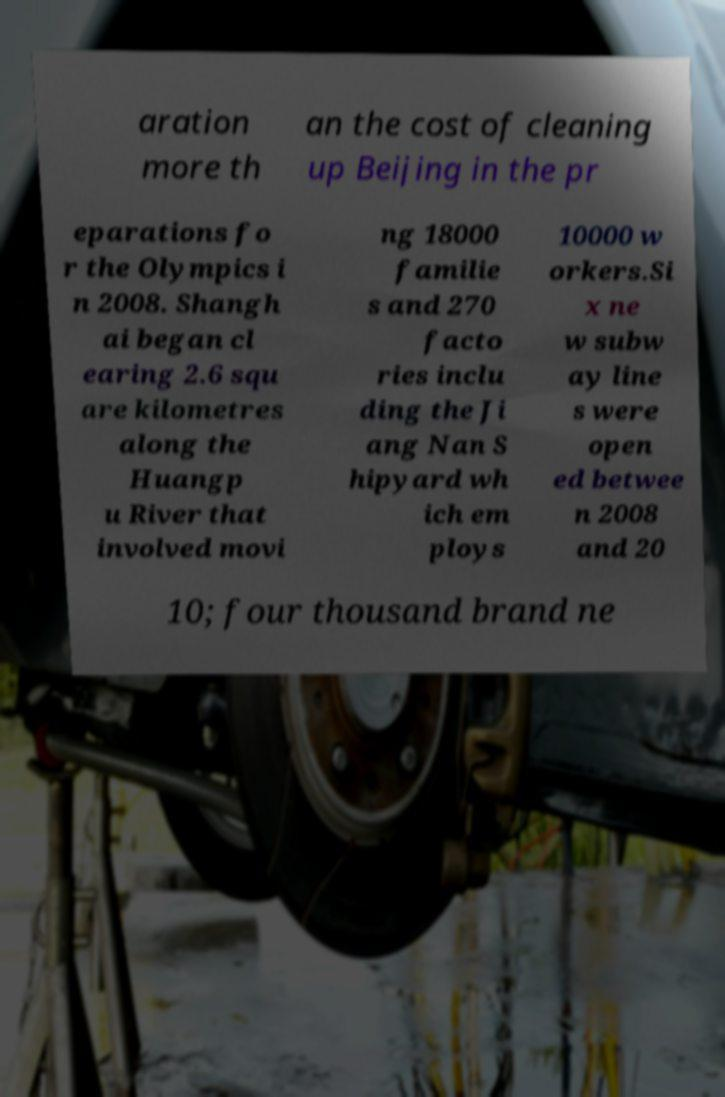What messages or text are displayed in this image? I need them in a readable, typed format. aration more th an the cost of cleaning up Beijing in the pr eparations fo r the Olympics i n 2008. Shangh ai began cl earing 2.6 squ are kilometres along the Huangp u River that involved movi ng 18000 familie s and 270 facto ries inclu ding the Ji ang Nan S hipyard wh ich em ploys 10000 w orkers.Si x ne w subw ay line s were open ed betwee n 2008 and 20 10; four thousand brand ne 